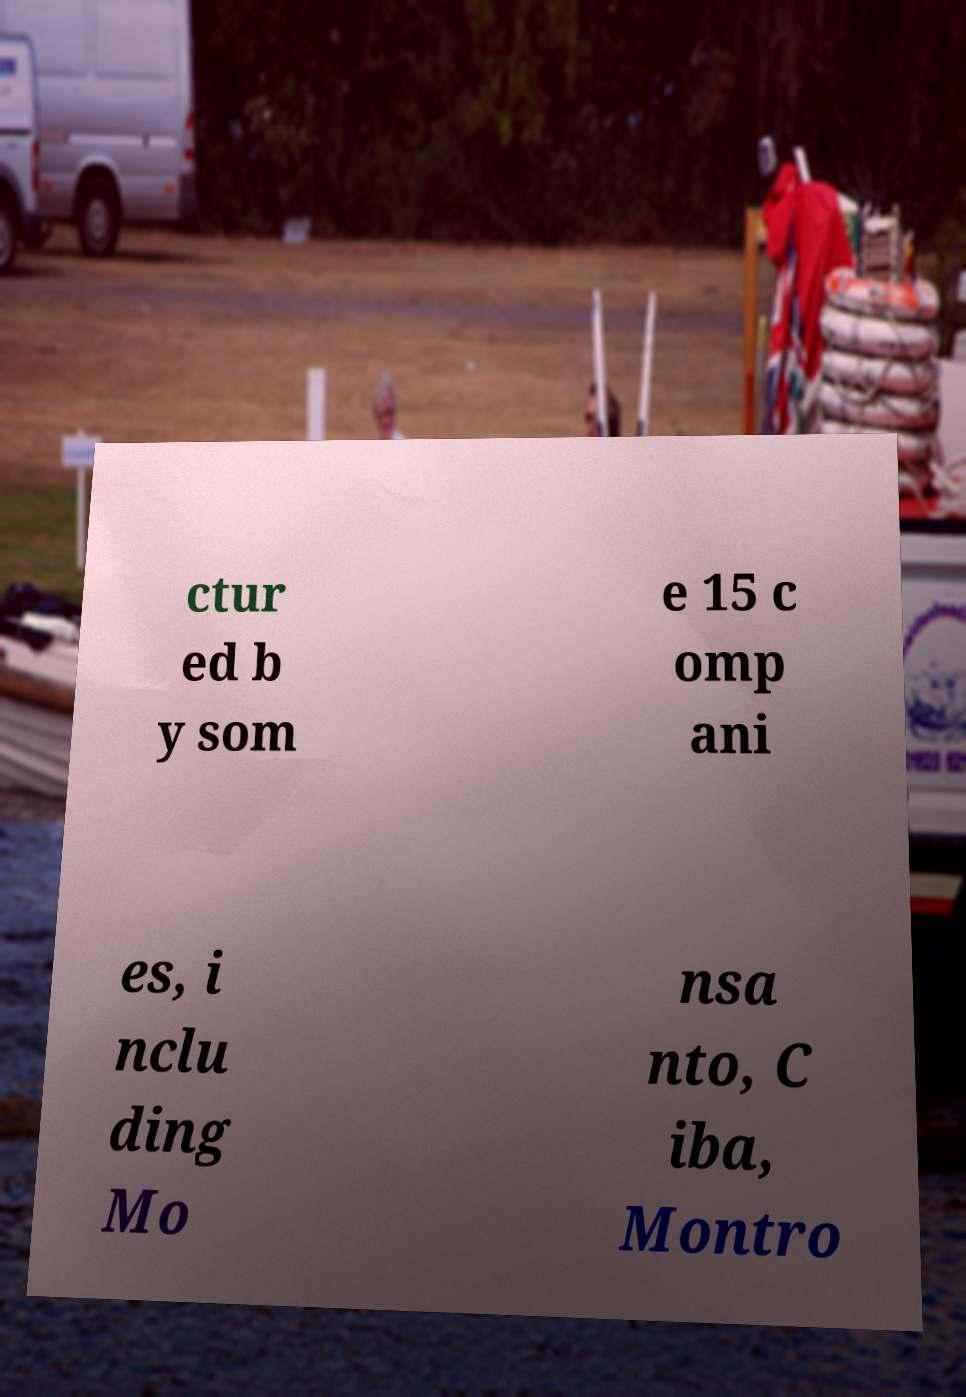There's text embedded in this image that I need extracted. Can you transcribe it verbatim? ctur ed b y som e 15 c omp ani es, i nclu ding Mo nsa nto, C iba, Montro 